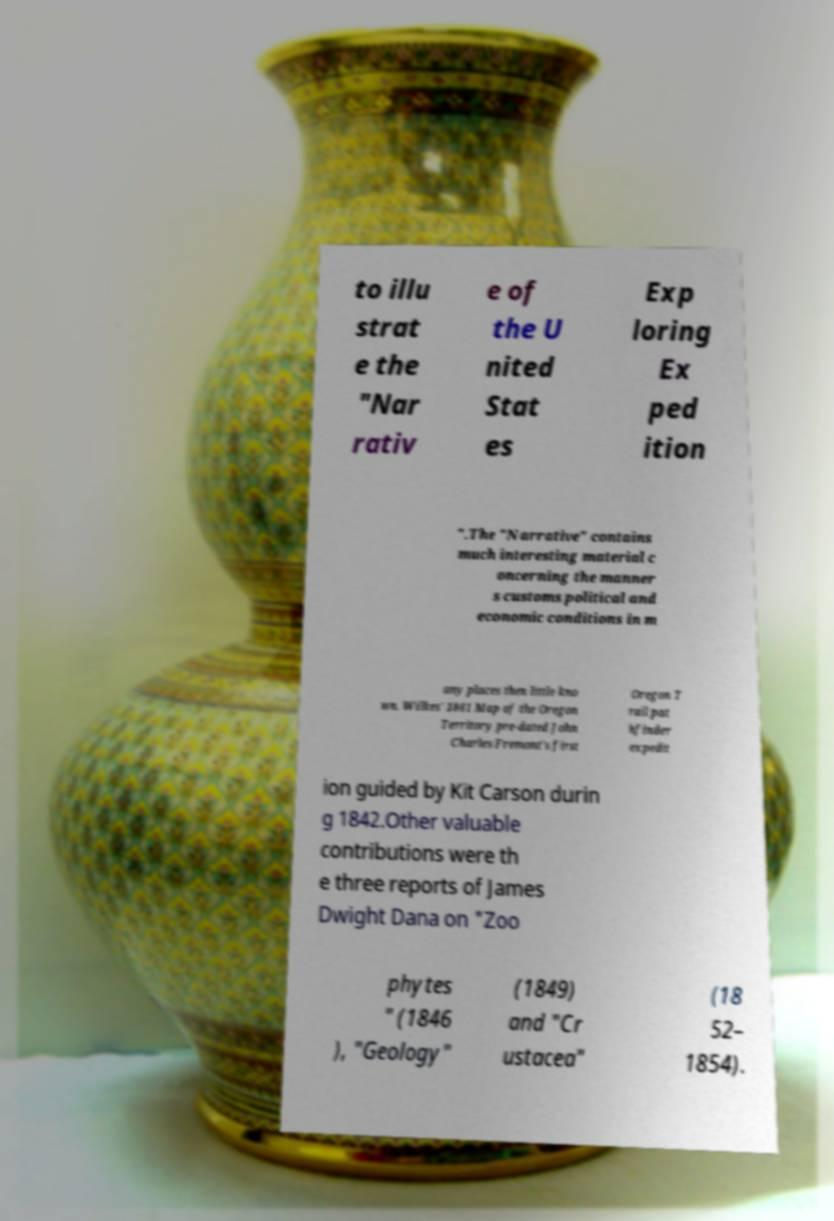Can you read and provide the text displayed in the image?This photo seems to have some interesting text. Can you extract and type it out for me? to illu strat e the "Nar rativ e of the U nited Stat es Exp loring Ex ped ition ".The "Narrative" contains much interesting material c oncerning the manner s customs political and economic conditions in m any places then little kno wn. Wilkes' 1841 Map of the Oregon Territory pre-dated John Charles Fremont's first Oregon T rail pat hfinder expedit ion guided by Kit Carson durin g 1842.Other valuable contributions were th e three reports of James Dwight Dana on "Zoo phytes " (1846 ), "Geology" (1849) and "Cr ustacea" (18 52– 1854). 